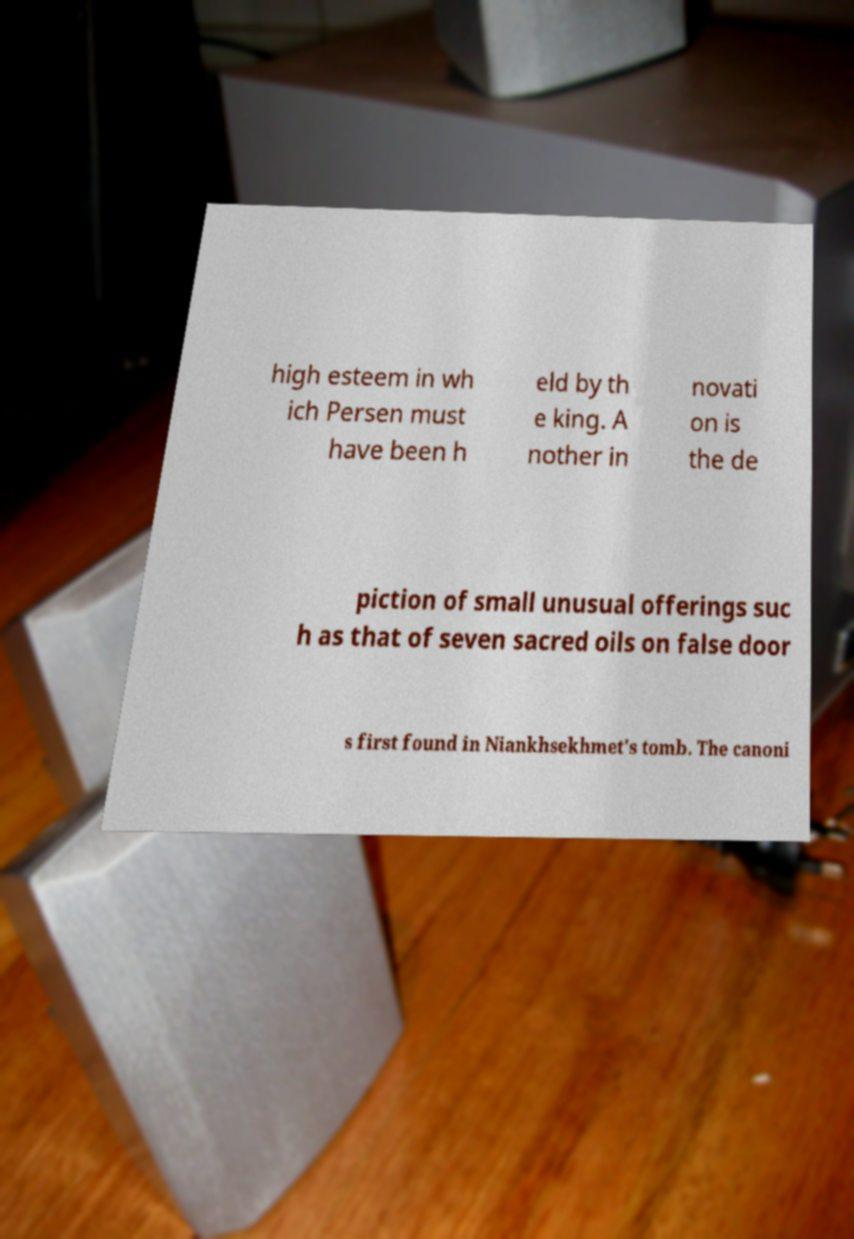Can you read and provide the text displayed in the image?This photo seems to have some interesting text. Can you extract and type it out for me? high esteem in wh ich Persen must have been h eld by th e king. A nother in novati on is the de piction of small unusual offerings suc h as that of seven sacred oils on false door s first found in Niankhsekhmet's tomb. The canoni 